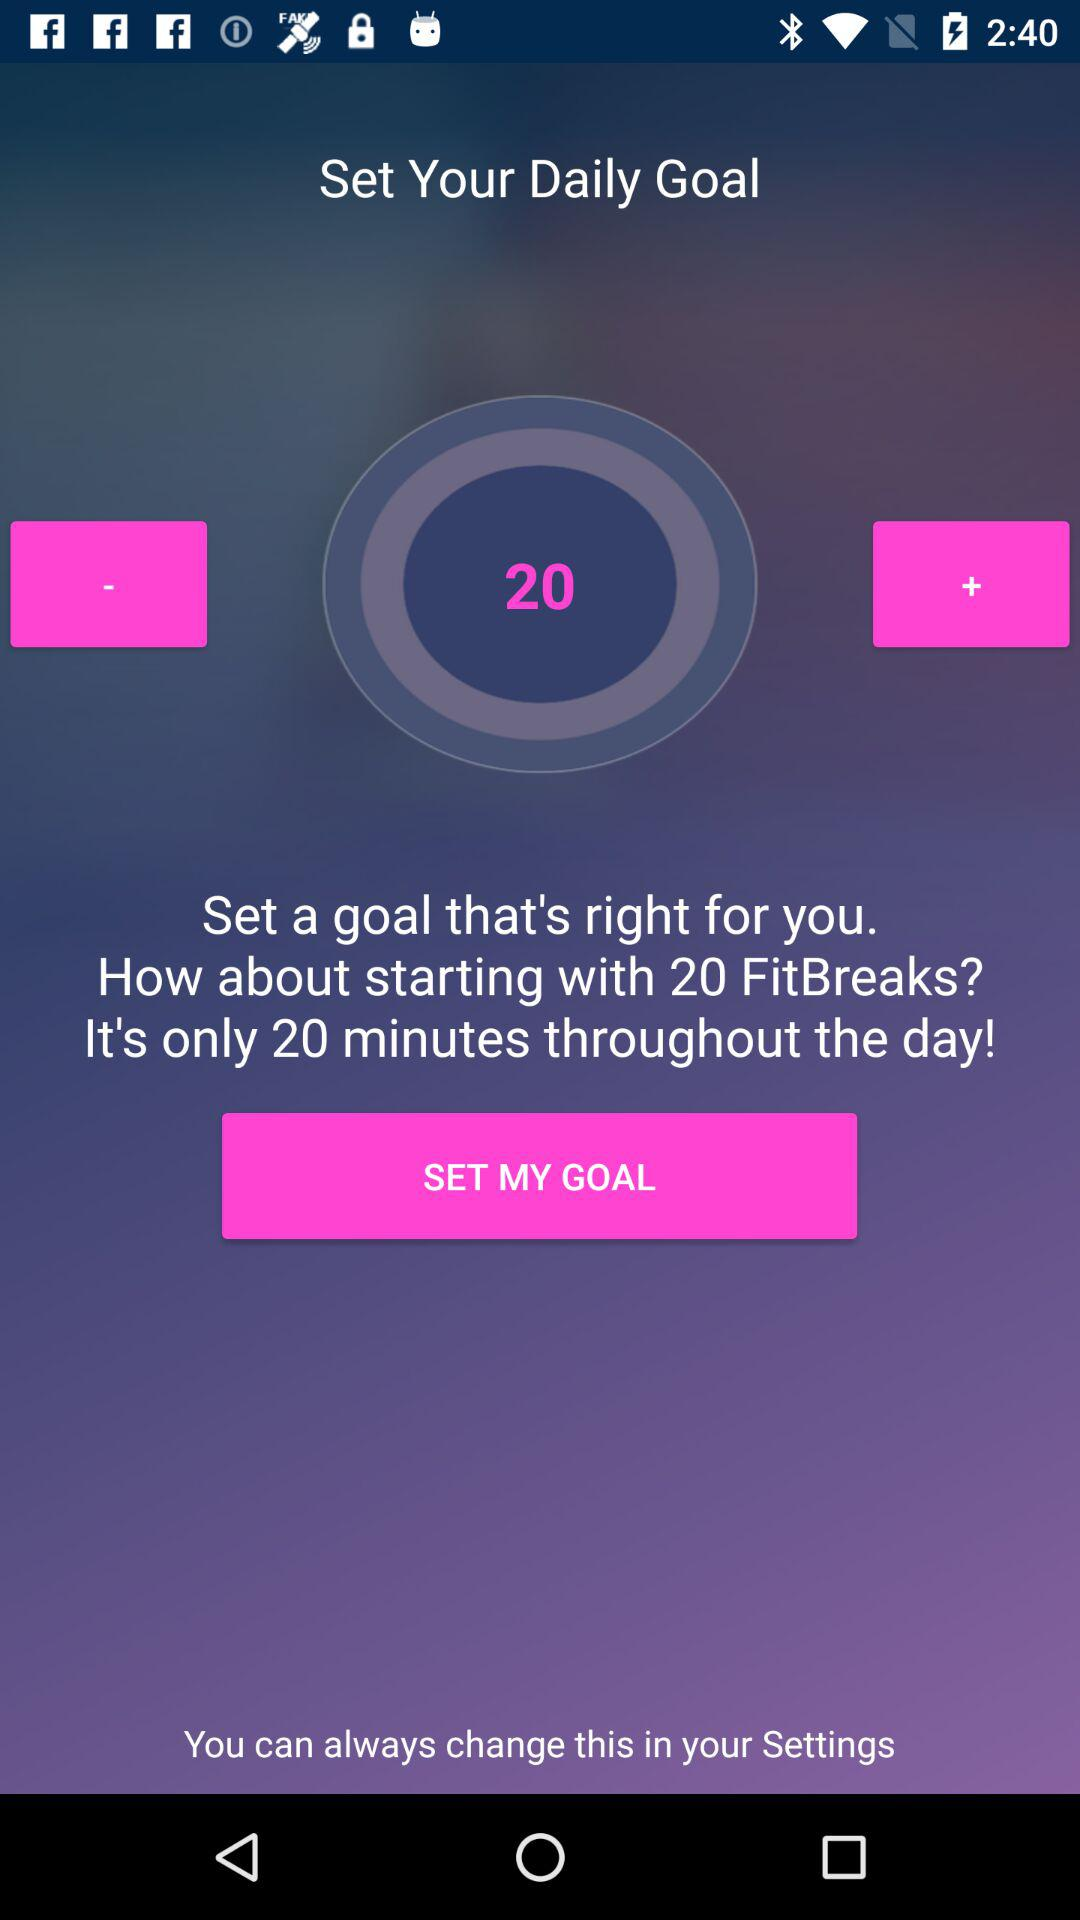How many minutes do you need to complete your goal?
Answer the question using a single word or phrase. 20 